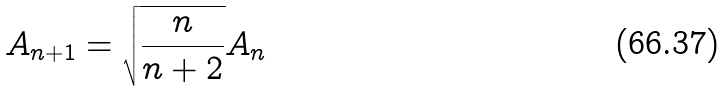<formula> <loc_0><loc_0><loc_500><loc_500>A _ { n + 1 } = \sqrt { \frac { n } { n + 2 } } A _ { n }</formula> 